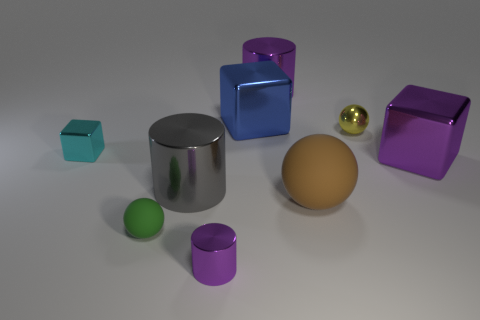Are there any repeating patterns or symmetries in the composition of the image? The image exhibits a sense of balance rather than strict symmetry, with objects of varying shapes and colors arranged in no discernable repeating pattern. Each object is unique in color and form, and while the composition is balanced, it is not symmetrical in a conventional sense. 